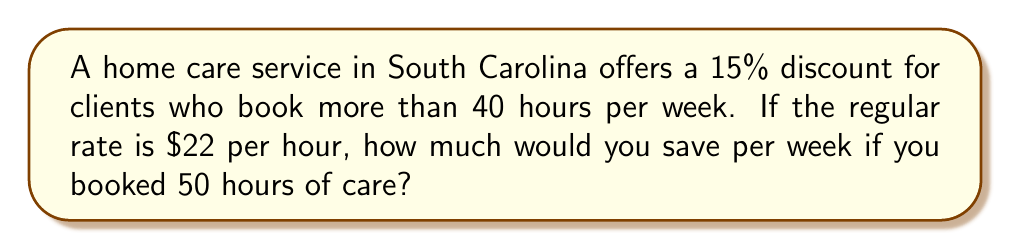Can you solve this math problem? Let's break this down step-by-step:

1. Calculate the regular cost for 50 hours:
   $$ 50 \text{ hours} \times \$22/\text{hour} = \$1100 $$

2. Calculate the discount percentage as a decimal:
   $$ 15\% = 15 \div 100 = 0.15 $$

3. Calculate the discount amount:
   $$ \$1100 \times 0.15 = \$165 $$

Therefore, you would save $165 per week with the discount.
Answer: $165 